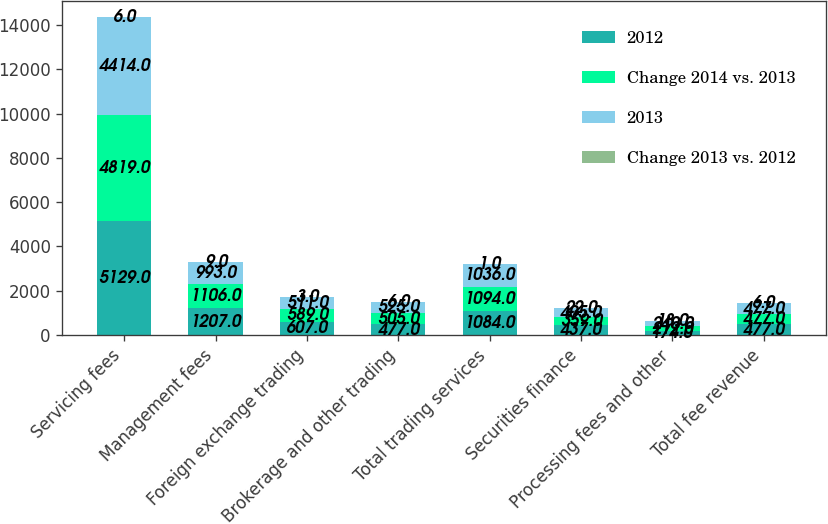<chart> <loc_0><loc_0><loc_500><loc_500><stacked_bar_chart><ecel><fcel>Servicing fees<fcel>Management fees<fcel>Foreign exchange trading<fcel>Brokerage and other trading<fcel>Total trading services<fcel>Securities finance<fcel>Processing fees and other<fcel>Total fee revenue<nl><fcel>2012<fcel>5129<fcel>1207<fcel>607<fcel>477<fcel>1084<fcel>437<fcel>174<fcel>477<nl><fcel>Change 2014 vs. 2013<fcel>4819<fcel>1106<fcel>589<fcel>505<fcel>1094<fcel>359<fcel>212<fcel>477<nl><fcel>2013<fcel>4414<fcel>993<fcel>511<fcel>525<fcel>1036<fcel>405<fcel>240<fcel>477<nl><fcel>Change 2013 vs. 2012<fcel>6<fcel>9<fcel>3<fcel>6<fcel>1<fcel>22<fcel>18<fcel>6<nl></chart> 